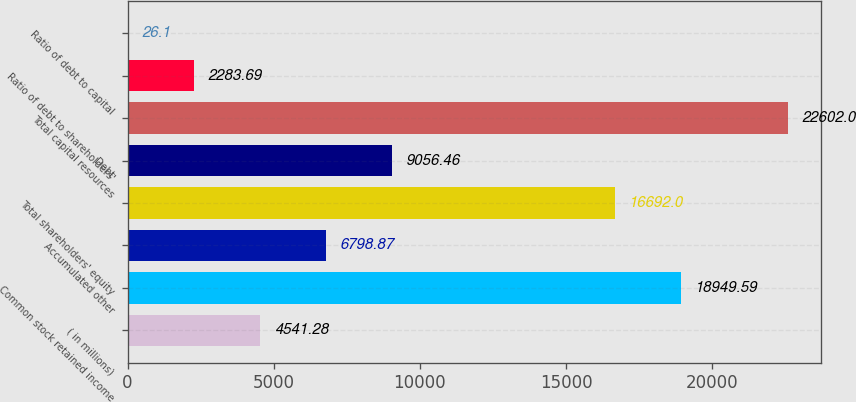<chart> <loc_0><loc_0><loc_500><loc_500><bar_chart><fcel>( in millions)<fcel>Common stock retained income<fcel>Accumulated other<fcel>Total shareholders' equity<fcel>Debt<fcel>Total capital resources<fcel>Ratio of debt to shareholders'<fcel>Ratio of debt to capital<nl><fcel>4541.28<fcel>18949.6<fcel>6798.87<fcel>16692<fcel>9056.46<fcel>22602<fcel>2283.69<fcel>26.1<nl></chart> 